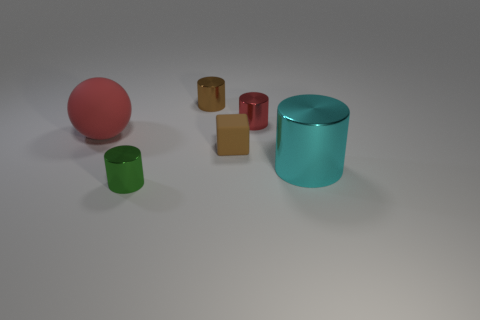Subtract all large cyan metallic cylinders. How many cylinders are left? 3 Subtract all green cylinders. How many cylinders are left? 3 Subtract 2 cylinders. How many cylinders are left? 2 Add 4 large red rubber balls. How many objects exist? 10 Subtract 0 blue cylinders. How many objects are left? 6 Subtract all balls. How many objects are left? 5 Subtract all yellow balls. Subtract all red cubes. How many balls are left? 1 Subtract all purple balls. How many purple cylinders are left? 0 Subtract all purple cylinders. Subtract all large spheres. How many objects are left? 5 Add 2 small brown rubber objects. How many small brown rubber objects are left? 3 